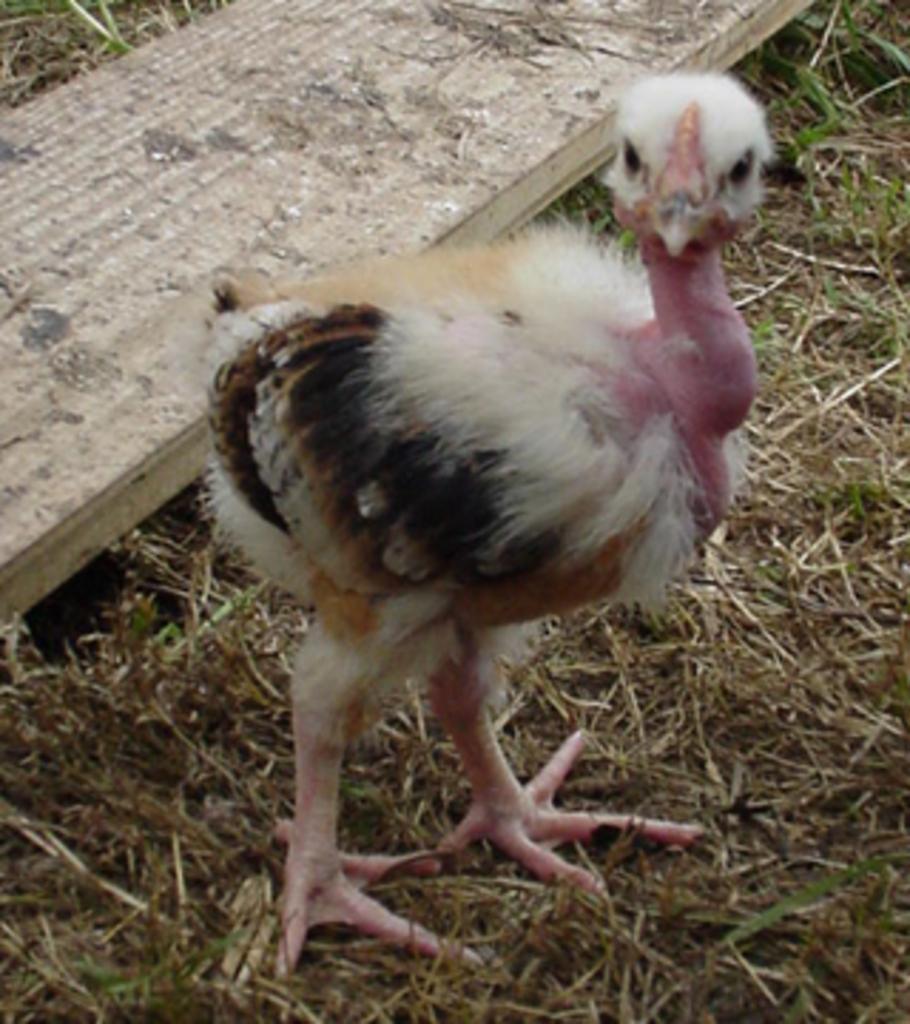Can you describe this image briefly? In the image we can see the bird, wooden sheet and the grass. 